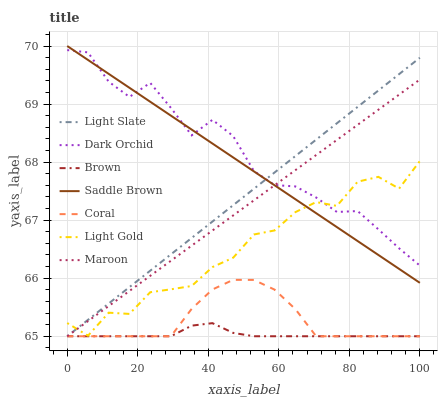Does Light Slate have the minimum area under the curve?
Answer yes or no. No. Does Light Slate have the maximum area under the curve?
Answer yes or no. No. Is Light Slate the smoothest?
Answer yes or no. No. Is Light Slate the roughest?
Answer yes or no. No. Does Dark Orchid have the lowest value?
Answer yes or no. No. Does Light Slate have the highest value?
Answer yes or no. No. Is Brown less than Light Gold?
Answer yes or no. Yes. Is Light Gold greater than Coral?
Answer yes or no. Yes. Does Brown intersect Light Gold?
Answer yes or no. No. 